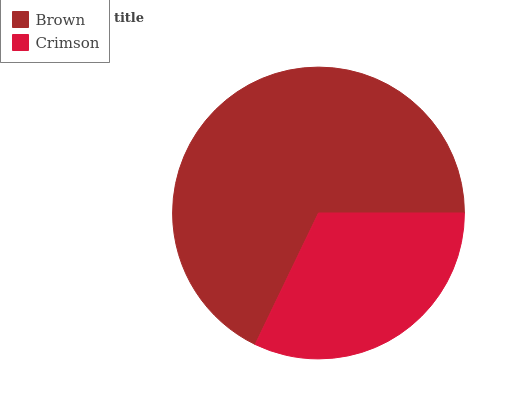Is Crimson the minimum?
Answer yes or no. Yes. Is Brown the maximum?
Answer yes or no. Yes. Is Crimson the maximum?
Answer yes or no. No. Is Brown greater than Crimson?
Answer yes or no. Yes. Is Crimson less than Brown?
Answer yes or no. Yes. Is Crimson greater than Brown?
Answer yes or no. No. Is Brown less than Crimson?
Answer yes or no. No. Is Brown the high median?
Answer yes or no. Yes. Is Crimson the low median?
Answer yes or no. Yes. Is Crimson the high median?
Answer yes or no. No. Is Brown the low median?
Answer yes or no. No. 